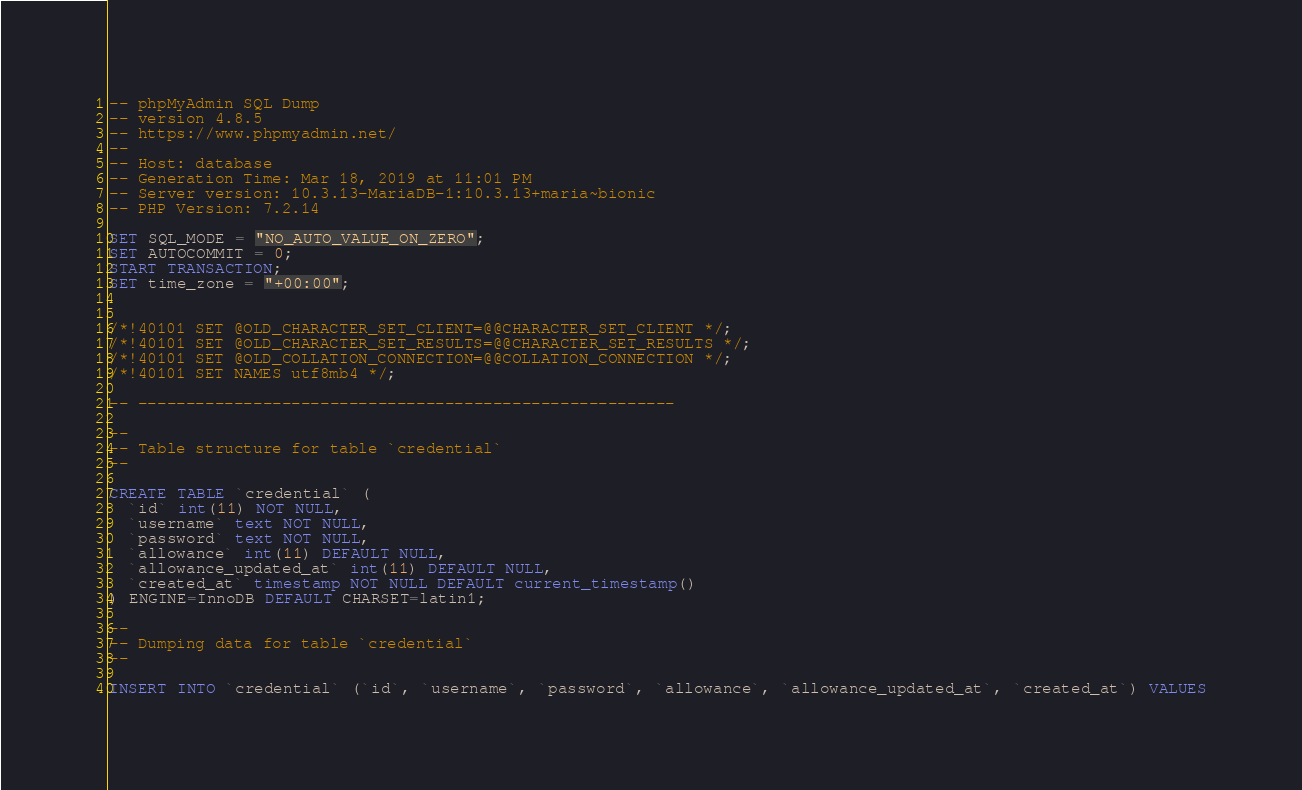Convert code to text. <code><loc_0><loc_0><loc_500><loc_500><_SQL_>-- phpMyAdmin SQL Dump
-- version 4.8.5
-- https://www.phpmyadmin.net/
--
-- Host: database
-- Generation Time: Mar 18, 2019 at 11:01 PM
-- Server version: 10.3.13-MariaDB-1:10.3.13+maria~bionic
-- PHP Version: 7.2.14

SET SQL_MODE = "NO_AUTO_VALUE_ON_ZERO";
SET AUTOCOMMIT = 0;
START TRANSACTION;
SET time_zone = "+00:00";


/*!40101 SET @OLD_CHARACTER_SET_CLIENT=@@CHARACTER_SET_CLIENT */;
/*!40101 SET @OLD_CHARACTER_SET_RESULTS=@@CHARACTER_SET_RESULTS */;
/*!40101 SET @OLD_COLLATION_CONNECTION=@@COLLATION_CONNECTION */;
/*!40101 SET NAMES utf8mb4 */;

-- --------------------------------------------------------

--
-- Table structure for table `credential`
--

CREATE TABLE `credential` (
  `id` int(11) NOT NULL,
  `username` text NOT NULL,
  `password` text NOT NULL,
  `allowance` int(11) DEFAULT NULL,
  `allowance_updated_at` int(11) DEFAULT NULL,
  `created_at` timestamp NOT NULL DEFAULT current_timestamp()
) ENGINE=InnoDB DEFAULT CHARSET=latin1;

--
-- Dumping data for table `credential`
--

INSERT INTO `credential` (`id`, `username`, `password`, `allowance`, `allowance_updated_at`, `created_at`) VALUES</code> 